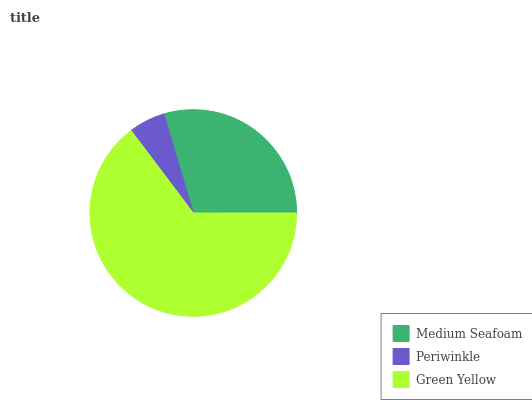Is Periwinkle the minimum?
Answer yes or no. Yes. Is Green Yellow the maximum?
Answer yes or no. Yes. Is Green Yellow the minimum?
Answer yes or no. No. Is Periwinkle the maximum?
Answer yes or no. No. Is Green Yellow greater than Periwinkle?
Answer yes or no. Yes. Is Periwinkle less than Green Yellow?
Answer yes or no. Yes. Is Periwinkle greater than Green Yellow?
Answer yes or no. No. Is Green Yellow less than Periwinkle?
Answer yes or no. No. Is Medium Seafoam the high median?
Answer yes or no. Yes. Is Medium Seafoam the low median?
Answer yes or no. Yes. Is Periwinkle the high median?
Answer yes or no. No. Is Periwinkle the low median?
Answer yes or no. No. 